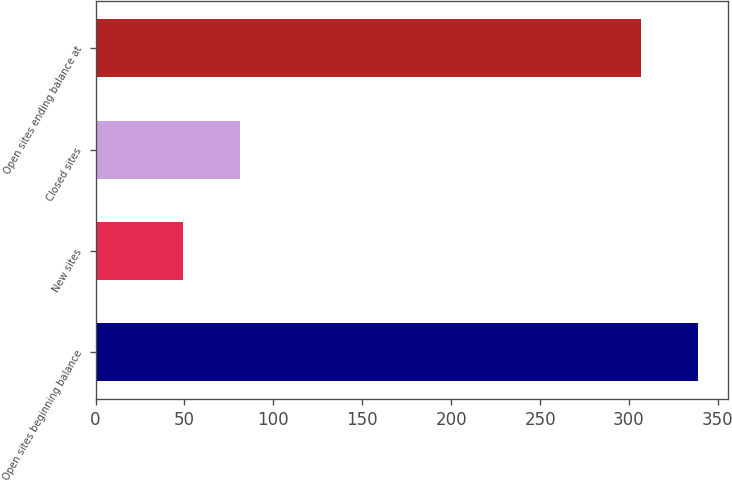Convert chart to OTSL. <chart><loc_0><loc_0><loc_500><loc_500><bar_chart><fcel>Open sites beginning balance<fcel>New sites<fcel>Closed sites<fcel>Open sites ending balance at<nl><fcel>339<fcel>49<fcel>81<fcel>307<nl></chart> 